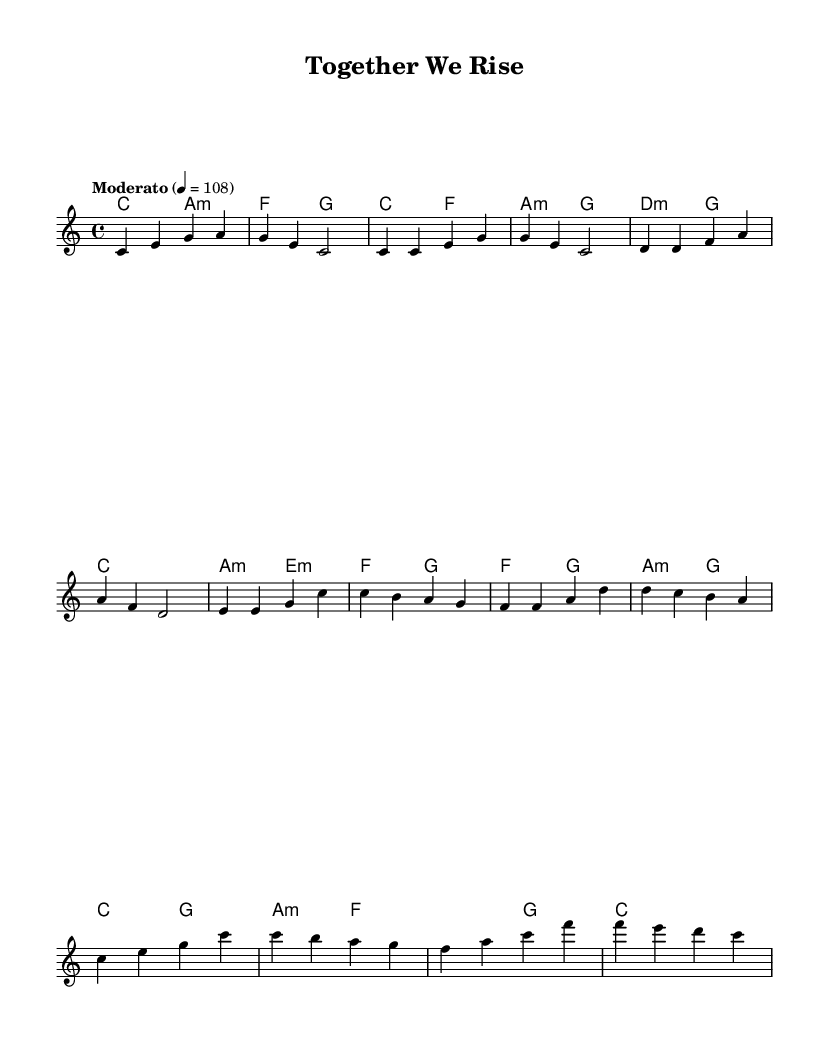What is the key signature of this music? The key signature is C major, which has no sharps or flats.
Answer: C major What is the time signature of this music? The time signature is indicated as 4/4, meaning there are four beats in each measure, and a quarter note gets one beat.
Answer: 4/4 What is the tempo marking of the piece? The tempo marking states "Moderato," which traditionally indicates a moderate speed of the piece, specifically at a metronome marking of 108 beats per minute.
Answer: Moderato How many measures are in the chorus section? By counting the measures indicated in the score, the chorus section consists of four measures.
Answer: 4 Which chord follows the F major chord at the end of the chorus? Looking at the harmonies for the chorus, the chord that follows F major is C major, as seen in the final measure of the chorus.
Answer: C In what section do we have the musical phrase "Together We Rise"? From the context of the sheet music, the phrase "Together We Rise" would typically align with the chorus section, where themes of unity and motivation are strongest.
Answer: Chorus What is the chord played during the pre-chorus? The chords for the pre-chorus include A minor, E minor, F, and G, forming a progression that supports the lifting message associated with social progress.
Answer: A minor 